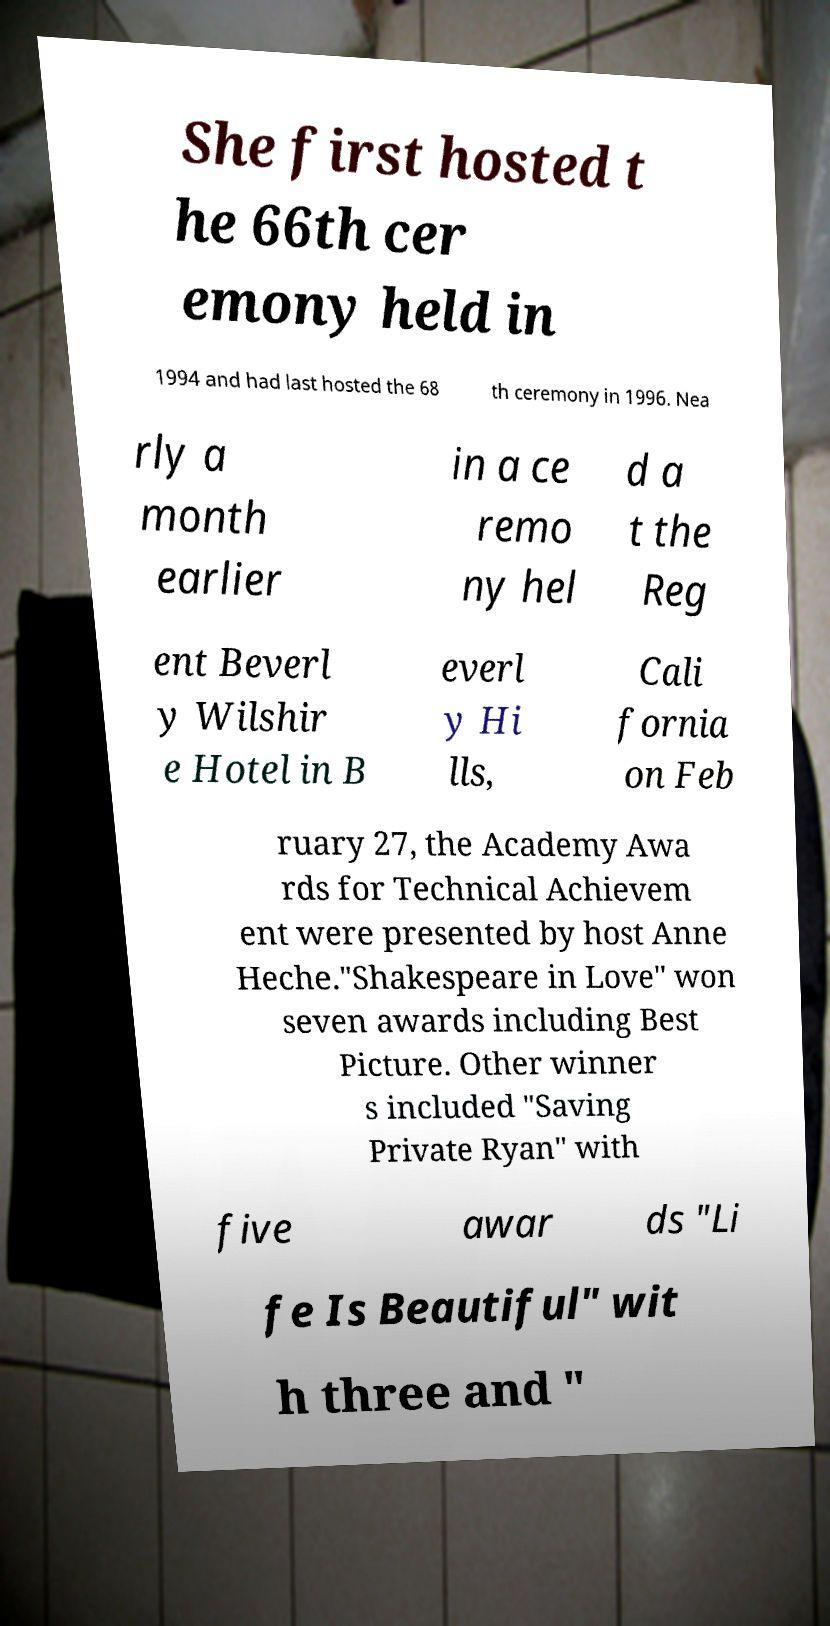Can you read and provide the text displayed in the image?This photo seems to have some interesting text. Can you extract and type it out for me? She first hosted t he 66th cer emony held in 1994 and had last hosted the 68 th ceremony in 1996. Nea rly a month earlier in a ce remo ny hel d a t the Reg ent Beverl y Wilshir e Hotel in B everl y Hi lls, Cali fornia on Feb ruary 27, the Academy Awa rds for Technical Achievem ent were presented by host Anne Heche."Shakespeare in Love" won seven awards including Best Picture. Other winner s included "Saving Private Ryan" with five awar ds "Li fe Is Beautiful" wit h three and " 